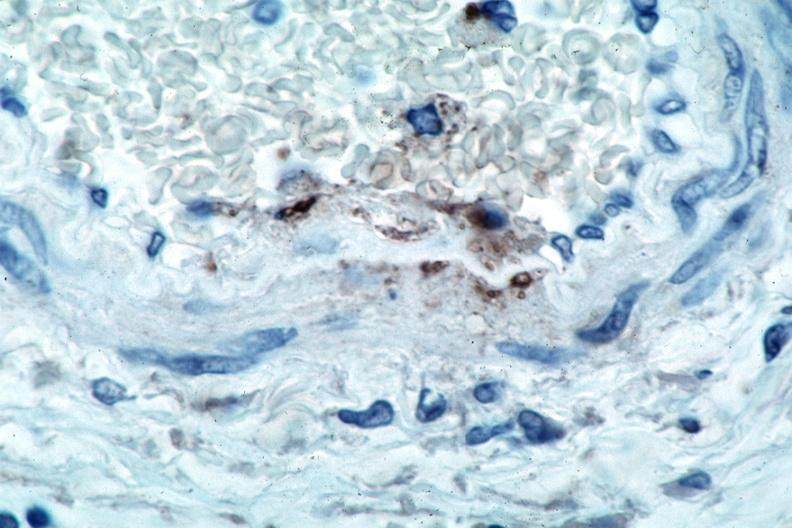what is rocky mountain spotted?
Answer the question using a single word or phrase. Fever 